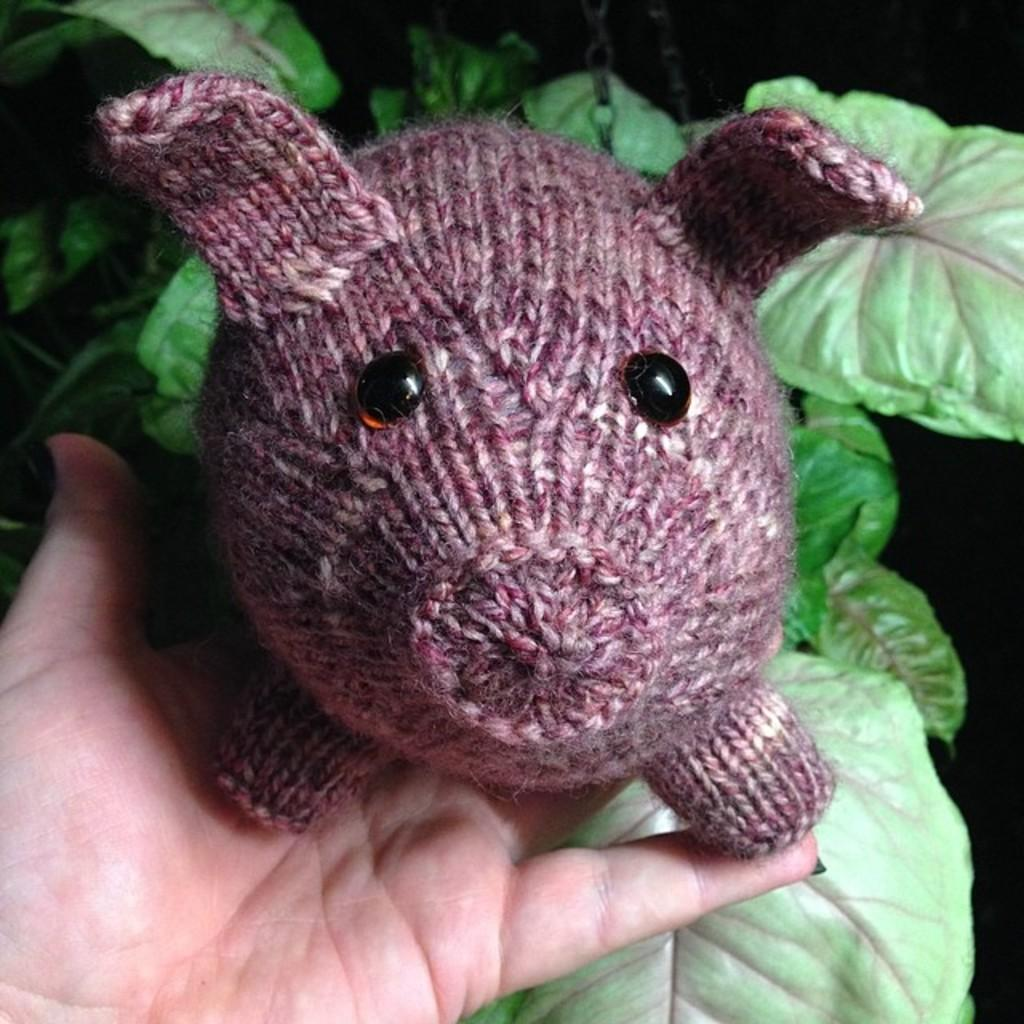What type of doll is present in the image? There is a pig doll made with wool in the image. Who is holding the doll in the image? The doll is in a person's hand. What can be seen in the background of the image? There are leaves visible in the image. How many kisses can be seen on the pig doll in the image? There are no kisses visible on the pig doll in the image. 